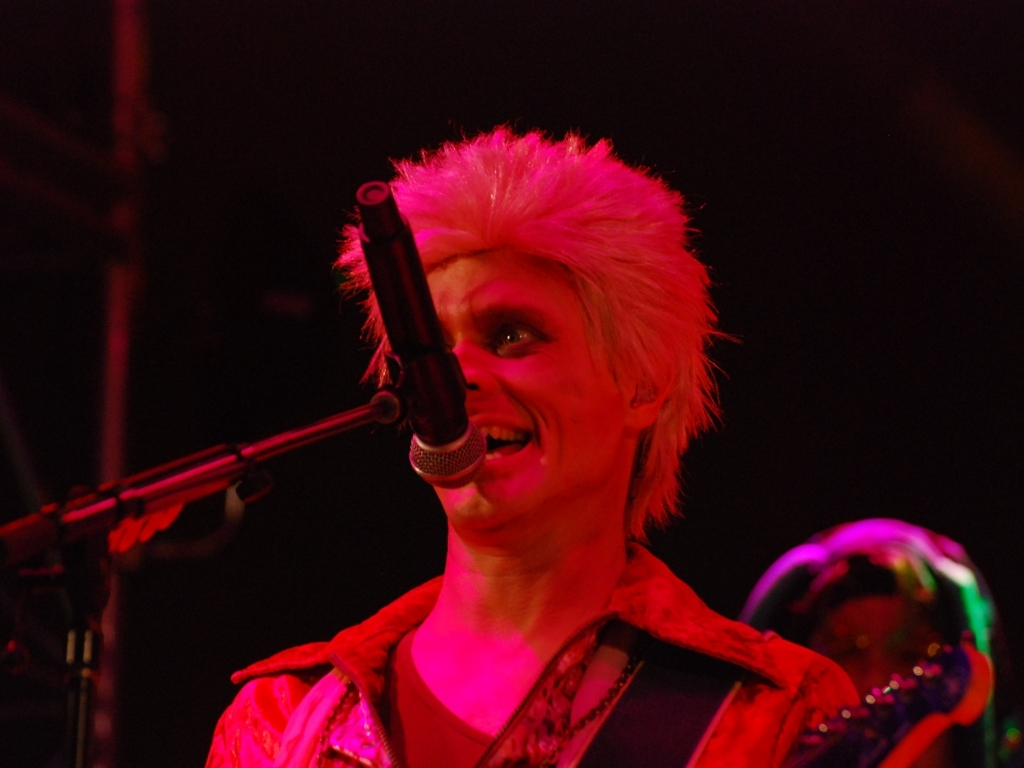What is the focus of the image?
A. singer and microphone
B. instruments
C. stage
Answer with the option's letter from the given choices directly.
 A. 